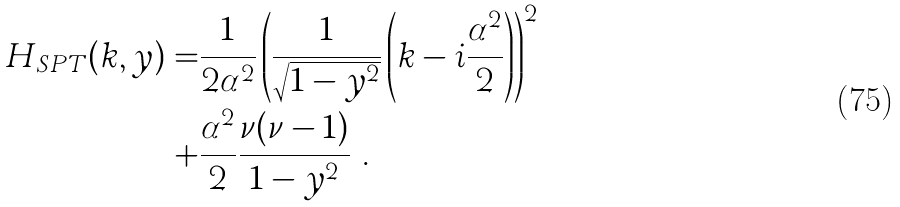<formula> <loc_0><loc_0><loc_500><loc_500>H _ { S P T } ( k , y ) = & \frac { 1 } { 2 \alpha ^ { 2 } } \left ( \frac { 1 } { \sqrt { 1 - y ^ { 2 } } } \left ( k - i \frac { \alpha ^ { 2 } } { 2 } \right ) \right ) ^ { 2 } \\ + & \frac { \alpha ^ { 2 } } { 2 } \frac { \nu ( \nu - 1 ) } { 1 - y ^ { 2 } } \ . \\</formula> 